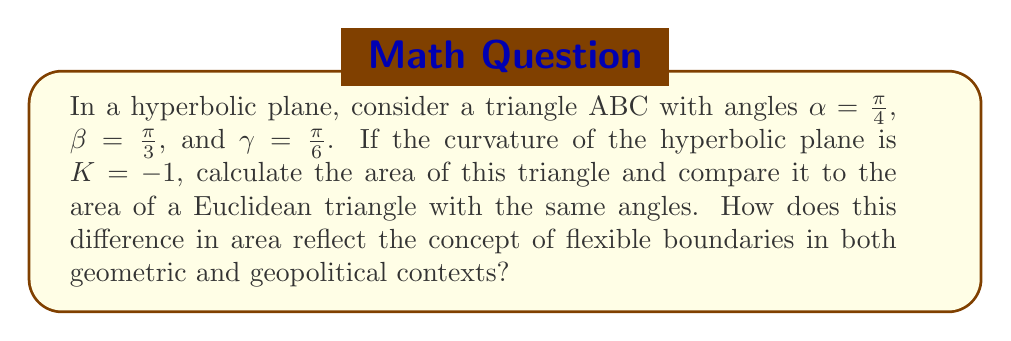Could you help me with this problem? 1. In hyperbolic geometry, the area of a triangle is given by the Gauss-Bonnet formula:
   $$A = -K(\alpha + \beta + \gamma - \pi)$$
   where $K$ is the curvature and $\alpha$, $\beta$, $\gamma$ are the angles of the triangle.

2. Substitute the given values:
   $$A = -(-1)(\frac{\pi}{4} + \frac{\pi}{3} + \frac{\pi}{6} - \pi)$$

3. Simplify:
   $$A = \frac{\pi}{4} + \frac{\pi}{3} + \frac{\pi}{6} - \pi = \frac{3\pi}{4} - \pi = -\frac{\pi}{4}$$

4. The area of the hyperbolic triangle is $\frac{\pi}{4}$ square units.

5. In Euclidean geometry, the sum of angles in a triangle is always $\pi$, and such a triangle cannot exist.

6. If we force these angles in Euclidean geometry, the area would be 0, as:
   $$A_{Euclidean} = \frac{\pi}{4} + \frac{\pi}{3} + \frac{\pi}{6} - \pi = 0$$

7. The difference in area ($\frac{\pi}{4}$ vs 0) reflects how hyperbolic geometry allows for more spatial flexibility, similar to how geopolitical boundaries can be more fluid in certain contexts.
Answer: Area (hyperbolic) = $\frac{\pi}{4}$; Area (Euclidean) = 0. Difference reflects spatial flexibility in hyperbolic geometry and geopolitics. 